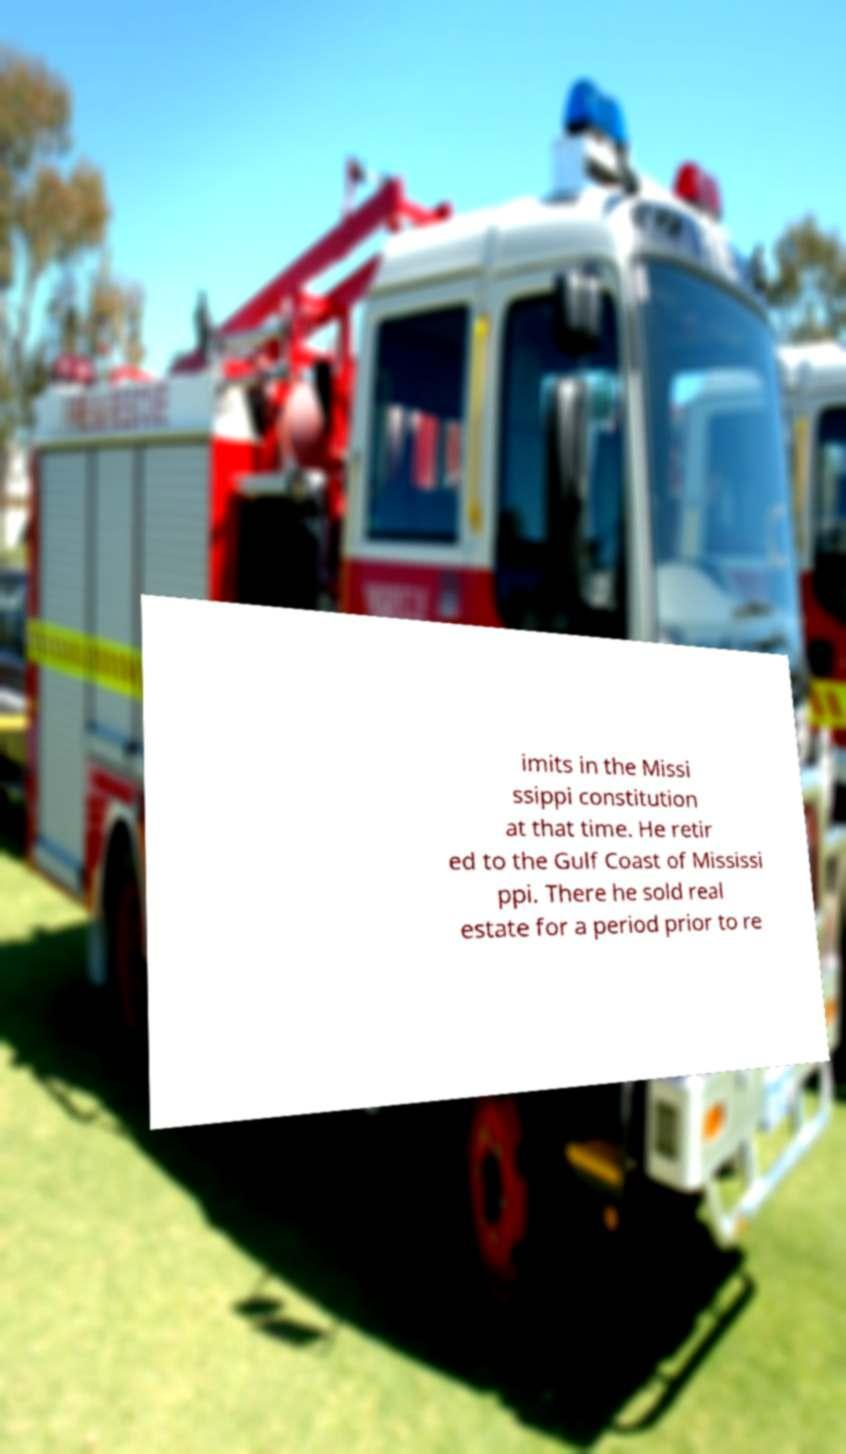Can you read and provide the text displayed in the image?This photo seems to have some interesting text. Can you extract and type it out for me? imits in the Missi ssippi constitution at that time. He retir ed to the Gulf Coast of Mississi ppi. There he sold real estate for a period prior to re 